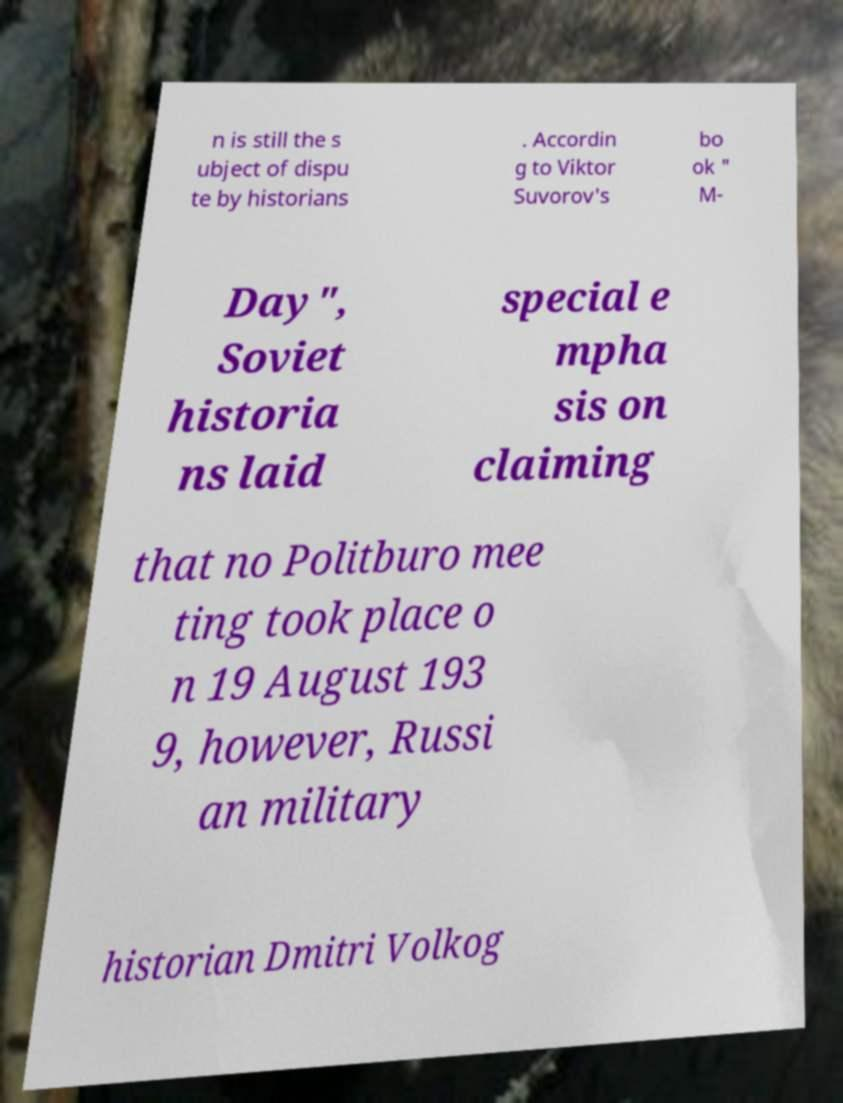Please read and relay the text visible in this image. What does it say? n is still the s ubject of dispu te by historians . Accordin g to Viktor Suvorov's bo ok " M- Day", Soviet historia ns laid special e mpha sis on claiming that no Politburo mee ting took place o n 19 August 193 9, however, Russi an military historian Dmitri Volkog 